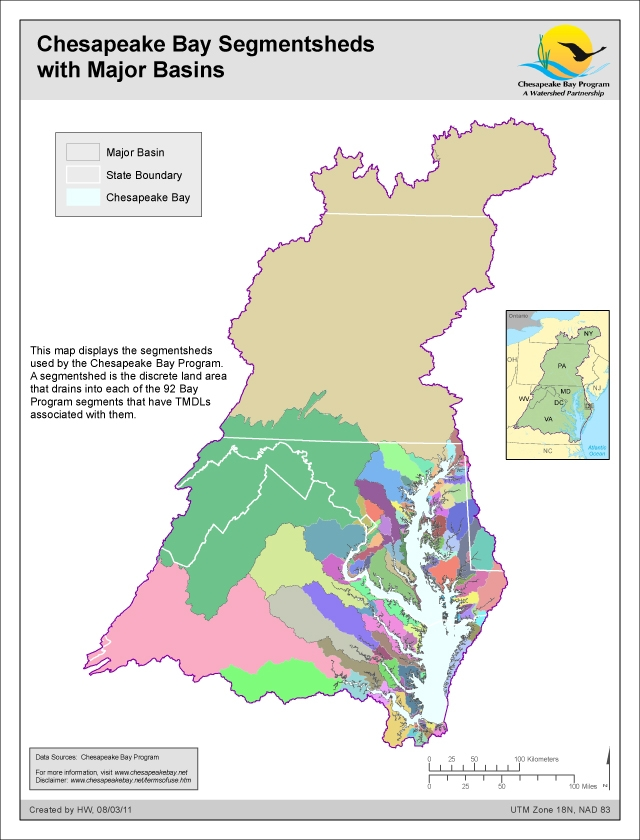How do the major basins depicted on the map influence water quality in the Chesapeake Bay? The major basins depicted on the map play a significant role in influencing water quality in the Chesapeake Bay. Each basin collects runoff, sediments, and pollutants from their respective areas, which eventually flow into the Bay. Land use practices, urban development, agricultural activities, and natural features within these basins impact the volume and quality of water entering the Bay. Understanding the characteristics of each basin helps in developing targeted strategies to reduce pollutants, manage runoff, and enhance water quality. Effective basin management involves collaborative efforts from all jurisdictions within each basin, addressing both point and non-point sources of pollution to ensure the health of the Chesapeake Bay.  If these segmentsheds were part of a grand fantasy world, how might magical creatures or phenomena be uniquely distributed among them, considering their geographical features? In a grand fantasy world, the segmentsheds of the Chesapeake Bay could be home to an array of magical creatures and phenomena, each uniquely adapted to their geographical features. The dense, forested segmentsheds might be inhabited by elusive dryads and treefolk, who protect the ancient woods with their enchantments. Riverine segmentsheds could be the realms of water sprites and merfolk, who keep the waters pristine with their magical abilities and ensure the health of aquatic life. The mountainous areas might harbor majestic griffins and dragons, whose presence shapes the very elements of the land with their formidable powers. Meanwhile, the plains and valleys could see the frolicking of unicorns and centaurs, whose harmonious existence with the land nurtures the flora and fauna. The diverse ecosystems of each segmentshed provide a vivid tapestry of magic, influencing not only the creatures that dwell within but also the mystical balance of the entire fantasy-world Chesapeake Bay. 